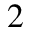<formula> <loc_0><loc_0><loc_500><loc_500>^ { 2 }</formula> 